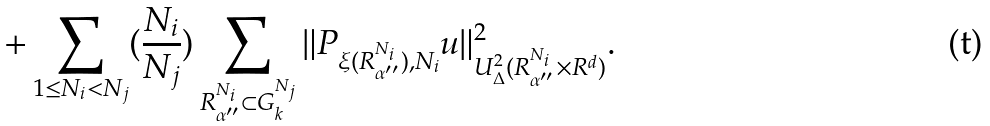<formula> <loc_0><loc_0><loc_500><loc_500>+ \sum _ { 1 \leq N _ { i } < N _ { j } } ( \frac { N _ { i } } { N _ { j } } ) \sum _ { R _ { \alpha ^ { \prime \prime } } ^ { N _ { i } } \subset G _ { k } ^ { N _ { j } } } \| P _ { \xi ( R _ { \alpha ^ { \prime \prime } } ^ { N _ { i } } ) , N _ { i } } u \| _ { U _ { \Delta } ^ { 2 } ( R _ { \alpha ^ { \prime \prime } } ^ { N _ { i } } \times R ^ { d } ) } ^ { 2 } .</formula> 